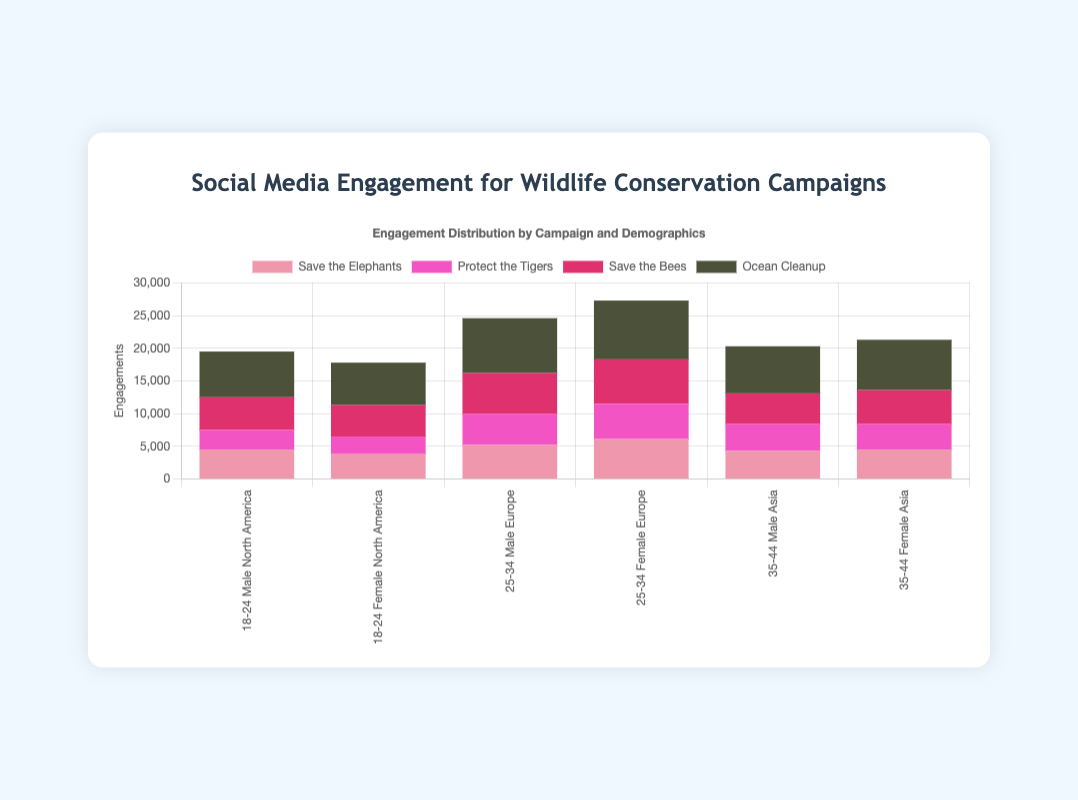Which campaign receives the highest engagement from the 25-34 age group in Europe? First, locate the bars related to the 25-34 age group in Europe for each campaign. Compare their heights (or values). The "Ocean Cleanup" campaign has the highest engagement in this group.
Answer: Ocean Cleanup Between "Save the Elephants" and "Protect the Tigers," which campaign has higher engagement among males aged 35-44 in Asia? Find the bars representing male engagement for the 35-44 age group in Asia for both campaigns. Compare the heights (or values) of these bars. "Save the Elephants" has higher male engagement than "Protect the Tigers."
Answer: Save the Elephants What is the total engagement for the "Save the Bees" campaign across all demographics? Add the engagements for "Save the Bees" from each demographic: 5000 + 4800 + 6200 + 6800 + 4700 + 5200. The result is the total engagement. 5000 + 4800 + 6200 + 6800 + 4700 + 5200 = 32700.
Answer: 32700 Which campaign has the lowest engagement among females aged 18-24 in North America? Identify the bars that represent female engagement for the age group 18-24 in North America, then find the lowest bar. The "Protect the Tigers" campaign has the lowest engagement here.
Answer: Protect the Tigers In the "Ocean Cleanup" campaign, which demographic group (age and gender) in Asia has a higher engagement? Compare the heights (or values) of the "Ocean Cleanup" bars for males and females aged 35-44 in Asia. The female group has higher engagement.
Answer: Female 35-44 How does the engagement for "Save the Elephants" among 25-34 females in Europe compare to "Save the Bees" for the same demographic? Locate the bars for "Save the Elephants" and "Save the Bees" for females aged 25-34 in Europe, then compare their heights (or values). The bar for "Save the Bees" is higher.
Answer: Save the Bees What is the average engagement of all campaigns in the 18-24 age group in North America? Find the engagements for all campaigns in the 18-24 group in North America: 4500 (Save the Elephants) + 3800 (Save the Elephants) + 3000 (Protect the Tigers) + 2700 (Protect the Tigers) + 5000 (Save the Bees) + 4800 (Save the Bees) + 7000 (Ocean Cleanup) + 6500 (Ocean Cleanup). Total engagements = 37300. Number of data points = 8. Average = 37300 / 8 = 4662.5.
Answer: 4662.5 Between males and females aged 25-34 in Europe, who shows more engagement overall? Add up all engagements for males and females aged 25-34 in Europe. Males: 5200 (Save the Elephants) + 4800 (Protect the Tigers) + 6200 (Save the Bees) + 8400 (Ocean Cleanup) = 24600. Females: 6100 (Save the Elephants) + 5400 (Protect the Tigers) + 6800 (Save the Bees) + 9000 (Ocean Cleanup) = 27300.
Answer: Females Is the engagement of "Protect the Tigers" in Asia higher among younger (18-24) or older (35-44) age groups? Compare the engagements of "Protect the Tigers" in Asia for the 18-24 and 35-44 age groups. 18-24: 0 (no data), 35-44: 4100 (male) + 3900 (female). Total for 35-44 is 8000, higher than younger groups.
Answer: Older (35-44) What is the combined engagement for "Ocean Cleanup" in Europe across all age groups? Add up the engagements for "Ocean Cleanup" in Europe for all age groups: 8400 (male 25-34) + 9000 (female 25-34). Total engagement = 17400.
Answer: 17400 